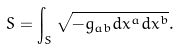Convert formula to latex. <formula><loc_0><loc_0><loc_500><loc_500>S = \int _ { S } \sqrt { - g _ { a b } d x ^ { a } d x ^ { b } } .</formula> 